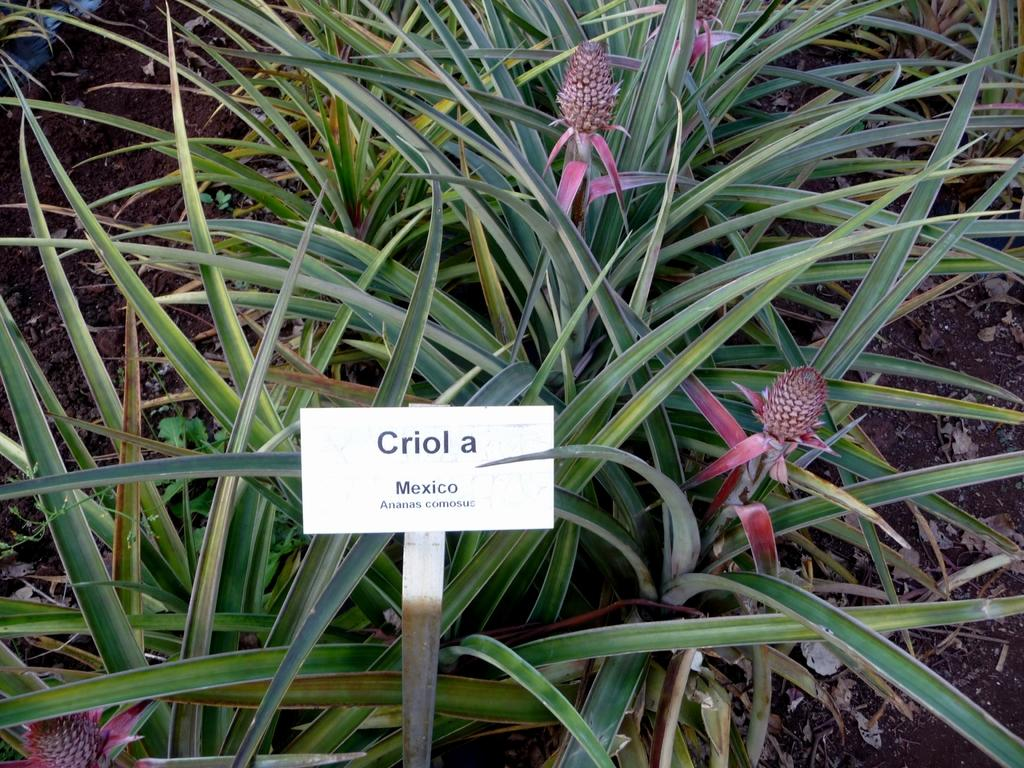What type of living organisms can be seen on the ground in the image? There are plants on the ground in the image. What object is placed in front of the plants? There is a board in front of the plants. What can be found on the board? There is text on the board. Can you tell me how many stamps are on the zebra in the image? There is no zebra or stamp present in the image. What type of tool is being used to plough the ground in the image? There is no ploughing activity or tool visible in the image. 